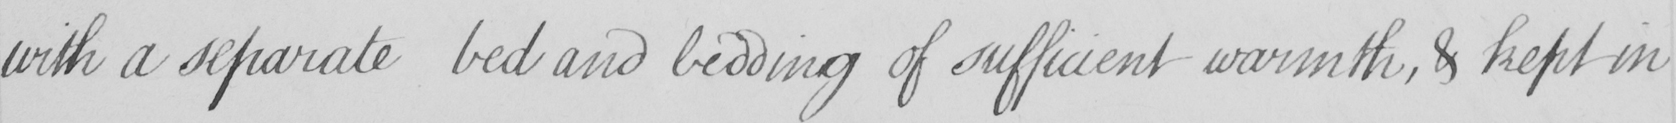Please provide the text content of this handwritten line. with a separate bed and bedding of sufficient warmth , & kept in 